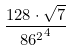Convert formula to latex. <formula><loc_0><loc_0><loc_500><loc_500>\frac { 1 2 8 \cdot \sqrt { 7 } } { { 8 6 ^ { 2 } } ^ { 4 } }</formula> 